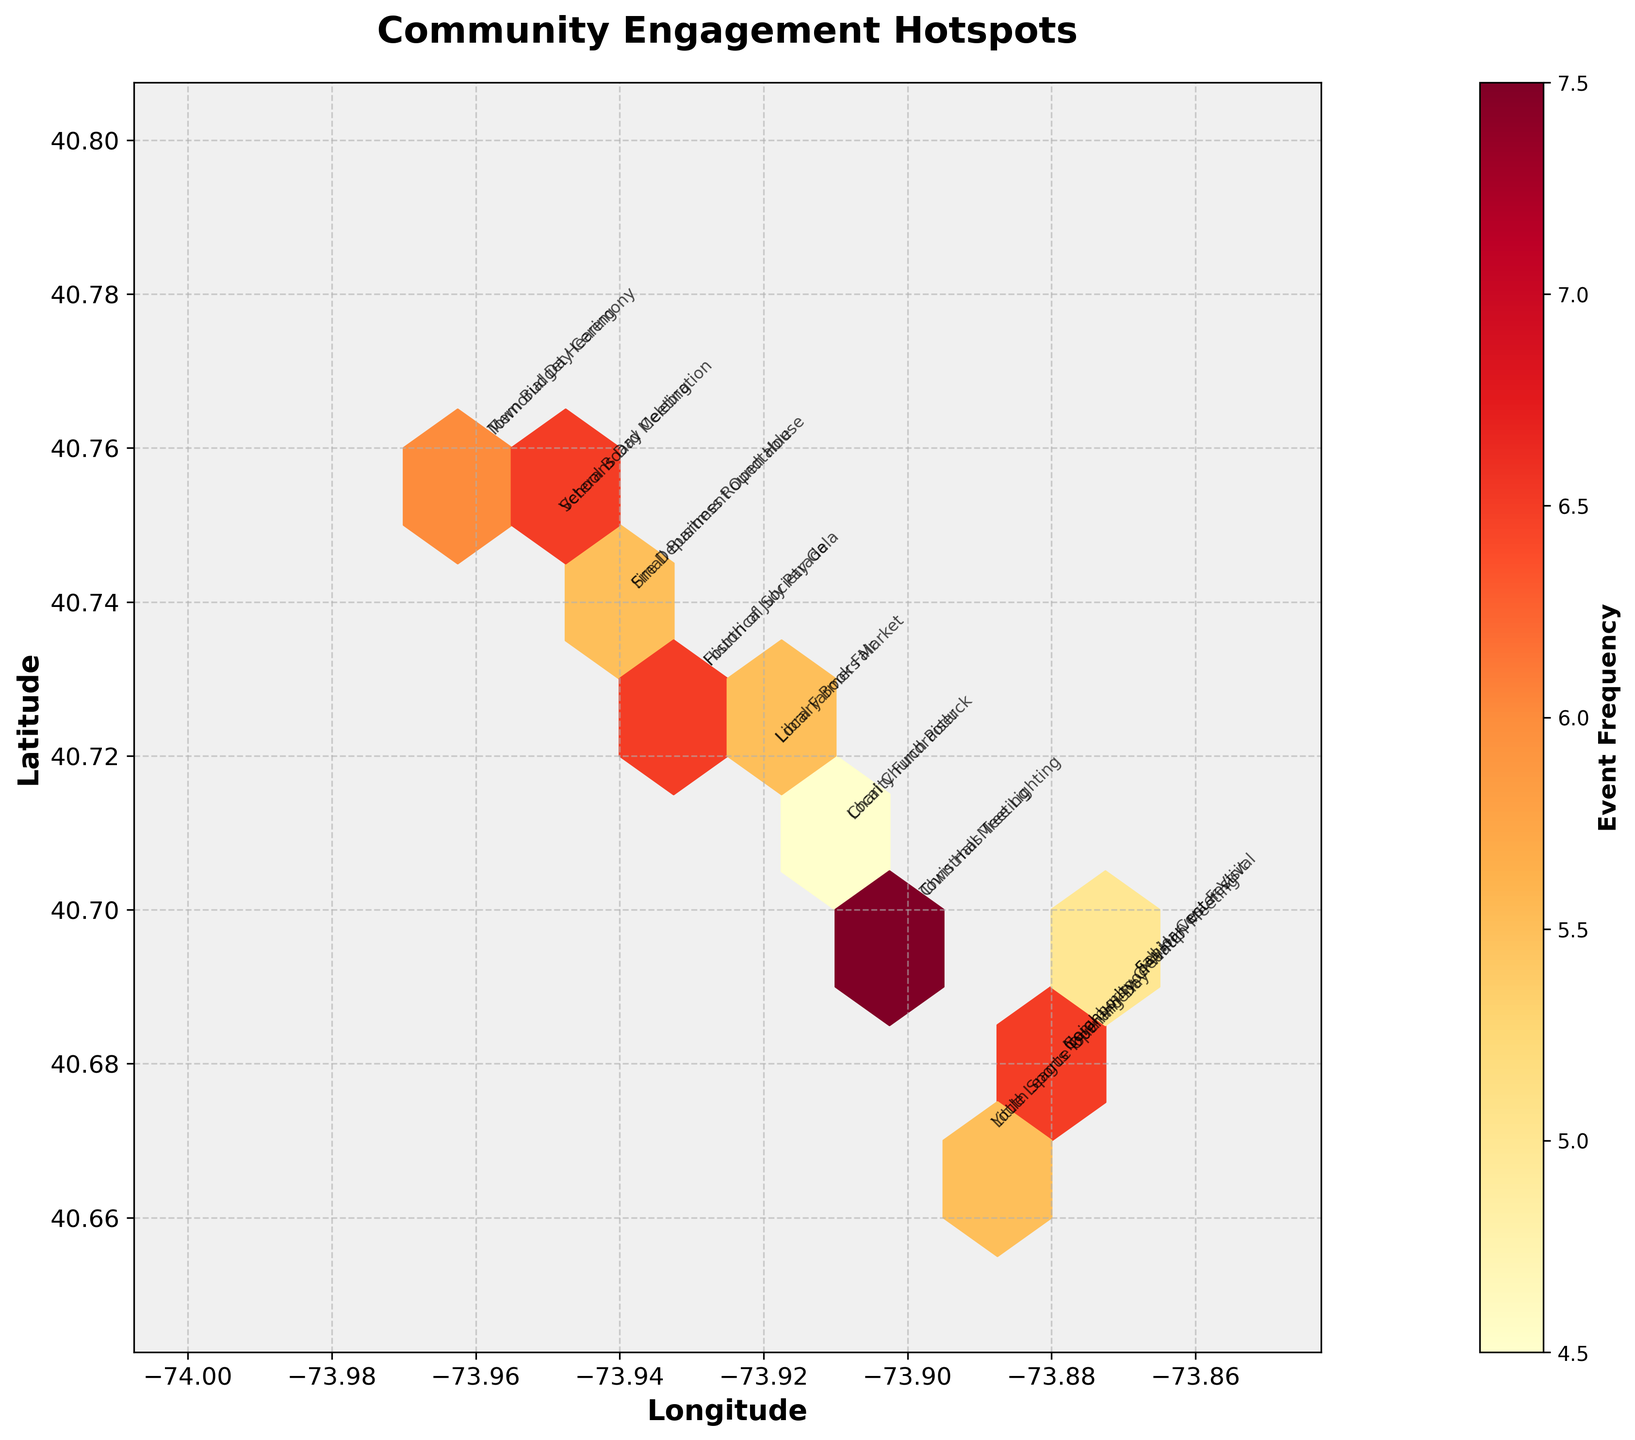Which area has the highest engagement according to the plot? The area with the most densely packed hexagons colored dark red indicates the highest engagement.
Answer: Around -73.93 longitude and 40.73 latitude How often was the 'Fourth of July Parade' held and where? Look for the annotation labeled "Fourth of July Parade" and check its frequency and coordinates.
Answer: 9 times at -73.93 longitude and 40.73 latitude Which event types have the same location? Find events with identical coordinates by checking the annotations' positions.
Answer: "Town Hall Meeting" and "Christmas Tree Lighting" both at -73.9, 40.7 What colors represent high-frequency events in this plot? Analyze the color scale shown in the color bar and compare with the hexagons' colors.
Answer: Darker red shades Is the frequency of "Memorial Day Ceremony" higher or lower than that of "Veterans Day Celebration"? Compare the annotated frequencies for both events.
Answer: Lower - "Memorial Day Ceremony" is 4, "Veterans Day Celebration" is 6 What's the overall geographic range covered by the events? Identify the minimum and maximum values on the x (longitude) and y (latitude) axes.
Answer: Longitude: -74 to -73.85, Latitude: 40.65 to 40.8 How many different event types are shown in the plot? Count the unique labels in the annotations.
Answer: 19 different event types What is the typical attendance frequency for community events as depicted in the plot? Examine the color bar and the most common shades on the plot. Most events appear in lighter to mid-red.
Answer: Around 5 to 8 times Which event type has the lowest frequency and where is it located? Look for the lightest-colored hexagon and read the corresponding annotation and frequency.
Answer: "Senior Center Visit" at -73.87, 40.69 with a frequency of 3 